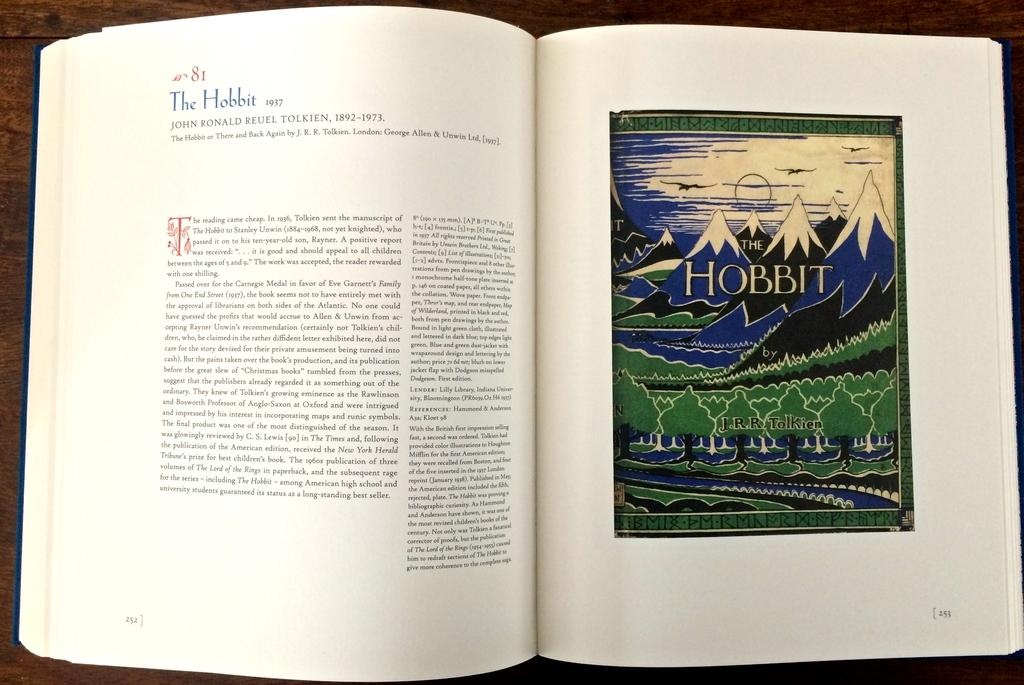What object can be seen in the image? There is a book in the image. Where is the book located? The book is placed on a table. What type of sock is the doctor wearing in the image? There is no doctor or sock present in the image; it only features a book placed on a table. 